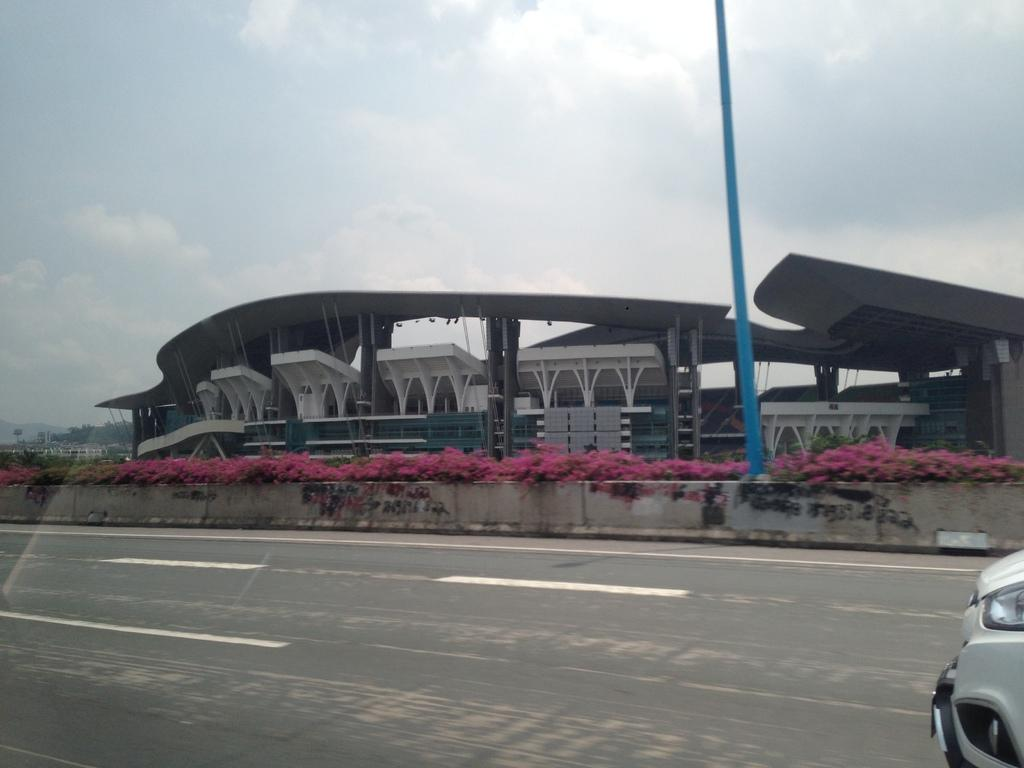What is the main feature in the center of the image? There is a road in the center of the image. What else can be seen in the image besides the road? There is a pole, a building, and a car on the right side of the image. What type of paste is being used to whip the tooth in the image? There is no paste, whip, or tooth present in the image. 